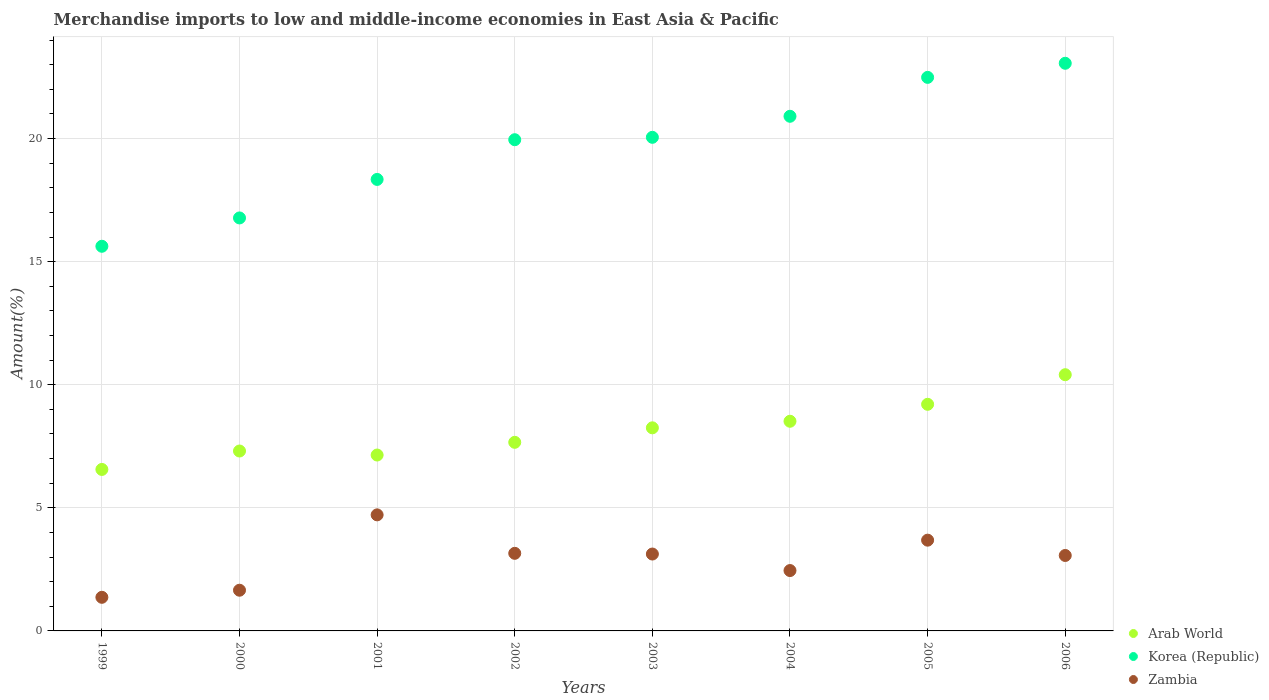How many different coloured dotlines are there?
Your response must be concise. 3. Is the number of dotlines equal to the number of legend labels?
Provide a short and direct response. Yes. What is the percentage of amount earned from merchandise imports in Arab World in 2004?
Your answer should be very brief. 8.52. Across all years, what is the maximum percentage of amount earned from merchandise imports in Zambia?
Your response must be concise. 4.71. Across all years, what is the minimum percentage of amount earned from merchandise imports in Zambia?
Make the answer very short. 1.37. What is the total percentage of amount earned from merchandise imports in Korea (Republic) in the graph?
Provide a short and direct response. 157.21. What is the difference between the percentage of amount earned from merchandise imports in Arab World in 2001 and that in 2003?
Keep it short and to the point. -1.11. What is the difference between the percentage of amount earned from merchandise imports in Zambia in 2003 and the percentage of amount earned from merchandise imports in Korea (Republic) in 1999?
Provide a succinct answer. -12.5. What is the average percentage of amount earned from merchandise imports in Zambia per year?
Offer a very short reply. 2.9. In the year 2002, what is the difference between the percentage of amount earned from merchandise imports in Zambia and percentage of amount earned from merchandise imports in Arab World?
Provide a succinct answer. -4.51. In how many years, is the percentage of amount earned from merchandise imports in Zambia greater than 10 %?
Your answer should be compact. 0. What is the ratio of the percentage of amount earned from merchandise imports in Korea (Republic) in 2001 to that in 2003?
Offer a very short reply. 0.91. What is the difference between the highest and the second highest percentage of amount earned from merchandise imports in Korea (Republic)?
Give a very brief answer. 0.57. What is the difference between the highest and the lowest percentage of amount earned from merchandise imports in Korea (Republic)?
Keep it short and to the point. 7.43. How many years are there in the graph?
Your response must be concise. 8. What is the difference between two consecutive major ticks on the Y-axis?
Offer a very short reply. 5. Where does the legend appear in the graph?
Your response must be concise. Bottom right. What is the title of the graph?
Your response must be concise. Merchandise imports to low and middle-income economies in East Asia & Pacific. What is the label or title of the Y-axis?
Ensure brevity in your answer.  Amount(%). What is the Amount(%) of Arab World in 1999?
Keep it short and to the point. 6.56. What is the Amount(%) of Korea (Republic) in 1999?
Keep it short and to the point. 15.63. What is the Amount(%) of Zambia in 1999?
Ensure brevity in your answer.  1.37. What is the Amount(%) of Arab World in 2000?
Your response must be concise. 7.31. What is the Amount(%) in Korea (Republic) in 2000?
Provide a short and direct response. 16.78. What is the Amount(%) in Zambia in 2000?
Your answer should be very brief. 1.65. What is the Amount(%) of Arab World in 2001?
Offer a terse response. 7.15. What is the Amount(%) of Korea (Republic) in 2001?
Offer a terse response. 18.34. What is the Amount(%) of Zambia in 2001?
Your answer should be compact. 4.71. What is the Amount(%) in Arab World in 2002?
Your answer should be very brief. 7.66. What is the Amount(%) of Korea (Republic) in 2002?
Your response must be concise. 19.96. What is the Amount(%) in Zambia in 2002?
Your response must be concise. 3.15. What is the Amount(%) of Arab World in 2003?
Offer a very short reply. 8.25. What is the Amount(%) of Korea (Republic) in 2003?
Ensure brevity in your answer.  20.05. What is the Amount(%) in Zambia in 2003?
Your answer should be compact. 3.12. What is the Amount(%) of Arab World in 2004?
Offer a terse response. 8.52. What is the Amount(%) in Korea (Republic) in 2004?
Offer a terse response. 20.91. What is the Amount(%) in Zambia in 2004?
Offer a very short reply. 2.45. What is the Amount(%) in Arab World in 2005?
Make the answer very short. 9.21. What is the Amount(%) of Korea (Republic) in 2005?
Your answer should be compact. 22.49. What is the Amount(%) of Zambia in 2005?
Your answer should be very brief. 3.69. What is the Amount(%) in Arab World in 2006?
Offer a terse response. 10.41. What is the Amount(%) in Korea (Republic) in 2006?
Make the answer very short. 23.06. What is the Amount(%) of Zambia in 2006?
Provide a short and direct response. 3.06. Across all years, what is the maximum Amount(%) of Arab World?
Ensure brevity in your answer.  10.41. Across all years, what is the maximum Amount(%) in Korea (Republic)?
Your answer should be very brief. 23.06. Across all years, what is the maximum Amount(%) of Zambia?
Offer a terse response. 4.71. Across all years, what is the minimum Amount(%) of Arab World?
Provide a succinct answer. 6.56. Across all years, what is the minimum Amount(%) of Korea (Republic)?
Your answer should be very brief. 15.63. Across all years, what is the minimum Amount(%) of Zambia?
Provide a succinct answer. 1.37. What is the total Amount(%) in Arab World in the graph?
Your answer should be very brief. 65.06. What is the total Amount(%) of Korea (Republic) in the graph?
Give a very brief answer. 157.21. What is the total Amount(%) in Zambia in the graph?
Keep it short and to the point. 23.21. What is the difference between the Amount(%) in Arab World in 1999 and that in 2000?
Your response must be concise. -0.75. What is the difference between the Amount(%) of Korea (Republic) in 1999 and that in 2000?
Your answer should be very brief. -1.15. What is the difference between the Amount(%) of Zambia in 1999 and that in 2000?
Provide a short and direct response. -0.29. What is the difference between the Amount(%) of Arab World in 1999 and that in 2001?
Your answer should be very brief. -0.59. What is the difference between the Amount(%) of Korea (Republic) in 1999 and that in 2001?
Your response must be concise. -2.72. What is the difference between the Amount(%) in Zambia in 1999 and that in 2001?
Provide a short and direct response. -3.35. What is the difference between the Amount(%) of Arab World in 1999 and that in 2002?
Your answer should be compact. -1.1. What is the difference between the Amount(%) in Korea (Republic) in 1999 and that in 2002?
Ensure brevity in your answer.  -4.33. What is the difference between the Amount(%) of Zambia in 1999 and that in 2002?
Offer a very short reply. -1.79. What is the difference between the Amount(%) of Arab World in 1999 and that in 2003?
Offer a terse response. -1.69. What is the difference between the Amount(%) in Korea (Republic) in 1999 and that in 2003?
Give a very brief answer. -4.43. What is the difference between the Amount(%) of Zambia in 1999 and that in 2003?
Keep it short and to the point. -1.76. What is the difference between the Amount(%) in Arab World in 1999 and that in 2004?
Offer a very short reply. -1.96. What is the difference between the Amount(%) of Korea (Republic) in 1999 and that in 2004?
Provide a short and direct response. -5.28. What is the difference between the Amount(%) in Zambia in 1999 and that in 2004?
Ensure brevity in your answer.  -1.09. What is the difference between the Amount(%) of Arab World in 1999 and that in 2005?
Your answer should be very brief. -2.65. What is the difference between the Amount(%) of Korea (Republic) in 1999 and that in 2005?
Keep it short and to the point. -6.86. What is the difference between the Amount(%) of Zambia in 1999 and that in 2005?
Offer a terse response. -2.32. What is the difference between the Amount(%) of Arab World in 1999 and that in 2006?
Provide a short and direct response. -3.85. What is the difference between the Amount(%) of Korea (Republic) in 1999 and that in 2006?
Give a very brief answer. -7.43. What is the difference between the Amount(%) of Zambia in 1999 and that in 2006?
Offer a terse response. -1.7. What is the difference between the Amount(%) in Arab World in 2000 and that in 2001?
Offer a very short reply. 0.16. What is the difference between the Amount(%) in Korea (Republic) in 2000 and that in 2001?
Your response must be concise. -1.56. What is the difference between the Amount(%) in Zambia in 2000 and that in 2001?
Provide a short and direct response. -3.06. What is the difference between the Amount(%) of Arab World in 2000 and that in 2002?
Give a very brief answer. -0.35. What is the difference between the Amount(%) in Korea (Republic) in 2000 and that in 2002?
Your answer should be compact. -3.18. What is the difference between the Amount(%) of Zambia in 2000 and that in 2002?
Provide a succinct answer. -1.5. What is the difference between the Amount(%) of Arab World in 2000 and that in 2003?
Your answer should be compact. -0.94. What is the difference between the Amount(%) of Korea (Republic) in 2000 and that in 2003?
Your answer should be compact. -3.28. What is the difference between the Amount(%) in Zambia in 2000 and that in 2003?
Your answer should be very brief. -1.47. What is the difference between the Amount(%) in Arab World in 2000 and that in 2004?
Your response must be concise. -1.21. What is the difference between the Amount(%) of Korea (Republic) in 2000 and that in 2004?
Keep it short and to the point. -4.13. What is the difference between the Amount(%) of Zambia in 2000 and that in 2004?
Provide a succinct answer. -0.8. What is the difference between the Amount(%) in Arab World in 2000 and that in 2005?
Provide a succinct answer. -1.9. What is the difference between the Amount(%) of Korea (Republic) in 2000 and that in 2005?
Ensure brevity in your answer.  -5.71. What is the difference between the Amount(%) of Zambia in 2000 and that in 2005?
Your answer should be compact. -2.03. What is the difference between the Amount(%) of Arab World in 2000 and that in 2006?
Offer a very short reply. -3.1. What is the difference between the Amount(%) in Korea (Republic) in 2000 and that in 2006?
Your answer should be compact. -6.28. What is the difference between the Amount(%) in Zambia in 2000 and that in 2006?
Provide a short and direct response. -1.41. What is the difference between the Amount(%) of Arab World in 2001 and that in 2002?
Ensure brevity in your answer.  -0.52. What is the difference between the Amount(%) of Korea (Republic) in 2001 and that in 2002?
Your answer should be very brief. -1.61. What is the difference between the Amount(%) in Zambia in 2001 and that in 2002?
Your response must be concise. 1.56. What is the difference between the Amount(%) in Arab World in 2001 and that in 2003?
Offer a very short reply. -1.11. What is the difference between the Amount(%) in Korea (Republic) in 2001 and that in 2003?
Make the answer very short. -1.71. What is the difference between the Amount(%) in Zambia in 2001 and that in 2003?
Give a very brief answer. 1.59. What is the difference between the Amount(%) in Arab World in 2001 and that in 2004?
Your response must be concise. -1.37. What is the difference between the Amount(%) in Korea (Republic) in 2001 and that in 2004?
Your response must be concise. -2.57. What is the difference between the Amount(%) in Zambia in 2001 and that in 2004?
Offer a terse response. 2.26. What is the difference between the Amount(%) of Arab World in 2001 and that in 2005?
Your answer should be very brief. -2.06. What is the difference between the Amount(%) in Korea (Republic) in 2001 and that in 2005?
Offer a very short reply. -4.15. What is the difference between the Amount(%) in Zambia in 2001 and that in 2005?
Keep it short and to the point. 1.03. What is the difference between the Amount(%) of Arab World in 2001 and that in 2006?
Your answer should be compact. -3.26. What is the difference between the Amount(%) in Korea (Republic) in 2001 and that in 2006?
Provide a succinct answer. -4.72. What is the difference between the Amount(%) of Zambia in 2001 and that in 2006?
Your answer should be very brief. 1.65. What is the difference between the Amount(%) in Arab World in 2002 and that in 2003?
Keep it short and to the point. -0.59. What is the difference between the Amount(%) of Korea (Republic) in 2002 and that in 2003?
Your response must be concise. -0.1. What is the difference between the Amount(%) of Zambia in 2002 and that in 2003?
Provide a short and direct response. 0.03. What is the difference between the Amount(%) of Arab World in 2002 and that in 2004?
Offer a terse response. -0.86. What is the difference between the Amount(%) of Korea (Republic) in 2002 and that in 2004?
Keep it short and to the point. -0.95. What is the difference between the Amount(%) in Zambia in 2002 and that in 2004?
Your response must be concise. 0.7. What is the difference between the Amount(%) of Arab World in 2002 and that in 2005?
Provide a short and direct response. -1.54. What is the difference between the Amount(%) of Korea (Republic) in 2002 and that in 2005?
Your answer should be compact. -2.53. What is the difference between the Amount(%) of Zambia in 2002 and that in 2005?
Your answer should be very brief. -0.53. What is the difference between the Amount(%) in Arab World in 2002 and that in 2006?
Provide a succinct answer. -2.75. What is the difference between the Amount(%) in Korea (Republic) in 2002 and that in 2006?
Give a very brief answer. -3.1. What is the difference between the Amount(%) of Zambia in 2002 and that in 2006?
Provide a short and direct response. 0.09. What is the difference between the Amount(%) of Arab World in 2003 and that in 2004?
Provide a succinct answer. -0.27. What is the difference between the Amount(%) in Korea (Republic) in 2003 and that in 2004?
Offer a very short reply. -0.85. What is the difference between the Amount(%) in Zambia in 2003 and that in 2004?
Provide a short and direct response. 0.67. What is the difference between the Amount(%) in Arab World in 2003 and that in 2005?
Keep it short and to the point. -0.96. What is the difference between the Amount(%) of Korea (Republic) in 2003 and that in 2005?
Your answer should be compact. -2.44. What is the difference between the Amount(%) of Zambia in 2003 and that in 2005?
Your response must be concise. -0.56. What is the difference between the Amount(%) in Arab World in 2003 and that in 2006?
Provide a succinct answer. -2.16. What is the difference between the Amount(%) in Korea (Republic) in 2003 and that in 2006?
Keep it short and to the point. -3.01. What is the difference between the Amount(%) in Zambia in 2003 and that in 2006?
Ensure brevity in your answer.  0.06. What is the difference between the Amount(%) of Arab World in 2004 and that in 2005?
Provide a succinct answer. -0.69. What is the difference between the Amount(%) in Korea (Republic) in 2004 and that in 2005?
Your answer should be compact. -1.58. What is the difference between the Amount(%) of Zambia in 2004 and that in 2005?
Offer a terse response. -1.23. What is the difference between the Amount(%) of Arab World in 2004 and that in 2006?
Your answer should be compact. -1.89. What is the difference between the Amount(%) in Korea (Republic) in 2004 and that in 2006?
Offer a terse response. -2.15. What is the difference between the Amount(%) in Zambia in 2004 and that in 2006?
Your answer should be very brief. -0.61. What is the difference between the Amount(%) in Arab World in 2005 and that in 2006?
Your response must be concise. -1.2. What is the difference between the Amount(%) in Korea (Republic) in 2005 and that in 2006?
Provide a short and direct response. -0.57. What is the difference between the Amount(%) of Zambia in 2005 and that in 2006?
Make the answer very short. 0.62. What is the difference between the Amount(%) in Arab World in 1999 and the Amount(%) in Korea (Republic) in 2000?
Your response must be concise. -10.22. What is the difference between the Amount(%) of Arab World in 1999 and the Amount(%) of Zambia in 2000?
Provide a short and direct response. 4.91. What is the difference between the Amount(%) of Korea (Republic) in 1999 and the Amount(%) of Zambia in 2000?
Keep it short and to the point. 13.97. What is the difference between the Amount(%) of Arab World in 1999 and the Amount(%) of Korea (Republic) in 2001?
Your answer should be compact. -11.78. What is the difference between the Amount(%) in Arab World in 1999 and the Amount(%) in Zambia in 2001?
Your answer should be very brief. 1.84. What is the difference between the Amount(%) in Korea (Republic) in 1999 and the Amount(%) in Zambia in 2001?
Provide a short and direct response. 10.91. What is the difference between the Amount(%) of Arab World in 1999 and the Amount(%) of Korea (Republic) in 2002?
Ensure brevity in your answer.  -13.4. What is the difference between the Amount(%) of Arab World in 1999 and the Amount(%) of Zambia in 2002?
Your response must be concise. 3.41. What is the difference between the Amount(%) of Korea (Republic) in 1999 and the Amount(%) of Zambia in 2002?
Your answer should be compact. 12.47. What is the difference between the Amount(%) of Arab World in 1999 and the Amount(%) of Korea (Republic) in 2003?
Your answer should be compact. -13.49. What is the difference between the Amount(%) in Arab World in 1999 and the Amount(%) in Zambia in 2003?
Ensure brevity in your answer.  3.44. What is the difference between the Amount(%) in Korea (Republic) in 1999 and the Amount(%) in Zambia in 2003?
Offer a terse response. 12.5. What is the difference between the Amount(%) in Arab World in 1999 and the Amount(%) in Korea (Republic) in 2004?
Your answer should be compact. -14.35. What is the difference between the Amount(%) of Arab World in 1999 and the Amount(%) of Zambia in 2004?
Your answer should be very brief. 4.11. What is the difference between the Amount(%) in Korea (Republic) in 1999 and the Amount(%) in Zambia in 2004?
Make the answer very short. 13.17. What is the difference between the Amount(%) in Arab World in 1999 and the Amount(%) in Korea (Republic) in 2005?
Give a very brief answer. -15.93. What is the difference between the Amount(%) in Arab World in 1999 and the Amount(%) in Zambia in 2005?
Provide a short and direct response. 2.87. What is the difference between the Amount(%) of Korea (Republic) in 1999 and the Amount(%) of Zambia in 2005?
Give a very brief answer. 11.94. What is the difference between the Amount(%) of Arab World in 1999 and the Amount(%) of Korea (Republic) in 2006?
Your response must be concise. -16.5. What is the difference between the Amount(%) in Arab World in 1999 and the Amount(%) in Zambia in 2006?
Make the answer very short. 3.5. What is the difference between the Amount(%) of Korea (Republic) in 1999 and the Amount(%) of Zambia in 2006?
Make the answer very short. 12.56. What is the difference between the Amount(%) in Arab World in 2000 and the Amount(%) in Korea (Republic) in 2001?
Provide a short and direct response. -11.03. What is the difference between the Amount(%) of Arab World in 2000 and the Amount(%) of Zambia in 2001?
Offer a terse response. 2.59. What is the difference between the Amount(%) of Korea (Republic) in 2000 and the Amount(%) of Zambia in 2001?
Offer a very short reply. 12.06. What is the difference between the Amount(%) of Arab World in 2000 and the Amount(%) of Korea (Republic) in 2002?
Provide a succinct answer. -12.65. What is the difference between the Amount(%) in Arab World in 2000 and the Amount(%) in Zambia in 2002?
Your response must be concise. 4.16. What is the difference between the Amount(%) in Korea (Republic) in 2000 and the Amount(%) in Zambia in 2002?
Your response must be concise. 13.62. What is the difference between the Amount(%) of Arab World in 2000 and the Amount(%) of Korea (Republic) in 2003?
Make the answer very short. -12.74. What is the difference between the Amount(%) in Arab World in 2000 and the Amount(%) in Zambia in 2003?
Make the answer very short. 4.18. What is the difference between the Amount(%) in Korea (Republic) in 2000 and the Amount(%) in Zambia in 2003?
Ensure brevity in your answer.  13.65. What is the difference between the Amount(%) of Arab World in 2000 and the Amount(%) of Korea (Republic) in 2004?
Offer a very short reply. -13.6. What is the difference between the Amount(%) in Arab World in 2000 and the Amount(%) in Zambia in 2004?
Make the answer very short. 4.86. What is the difference between the Amount(%) in Korea (Republic) in 2000 and the Amount(%) in Zambia in 2004?
Your response must be concise. 14.32. What is the difference between the Amount(%) of Arab World in 2000 and the Amount(%) of Korea (Republic) in 2005?
Offer a terse response. -15.18. What is the difference between the Amount(%) in Arab World in 2000 and the Amount(%) in Zambia in 2005?
Your response must be concise. 3.62. What is the difference between the Amount(%) of Korea (Republic) in 2000 and the Amount(%) of Zambia in 2005?
Your answer should be very brief. 13.09. What is the difference between the Amount(%) of Arab World in 2000 and the Amount(%) of Korea (Republic) in 2006?
Keep it short and to the point. -15.75. What is the difference between the Amount(%) in Arab World in 2000 and the Amount(%) in Zambia in 2006?
Provide a short and direct response. 4.24. What is the difference between the Amount(%) of Korea (Republic) in 2000 and the Amount(%) of Zambia in 2006?
Make the answer very short. 13.71. What is the difference between the Amount(%) of Arab World in 2001 and the Amount(%) of Korea (Republic) in 2002?
Your response must be concise. -12.81. What is the difference between the Amount(%) in Arab World in 2001 and the Amount(%) in Zambia in 2002?
Give a very brief answer. 3.99. What is the difference between the Amount(%) of Korea (Republic) in 2001 and the Amount(%) of Zambia in 2002?
Provide a short and direct response. 15.19. What is the difference between the Amount(%) in Arab World in 2001 and the Amount(%) in Korea (Republic) in 2003?
Give a very brief answer. -12.91. What is the difference between the Amount(%) in Arab World in 2001 and the Amount(%) in Zambia in 2003?
Your response must be concise. 4.02. What is the difference between the Amount(%) of Korea (Republic) in 2001 and the Amount(%) of Zambia in 2003?
Your answer should be compact. 15.22. What is the difference between the Amount(%) in Arab World in 2001 and the Amount(%) in Korea (Republic) in 2004?
Your response must be concise. -13.76. What is the difference between the Amount(%) in Arab World in 2001 and the Amount(%) in Zambia in 2004?
Your answer should be very brief. 4.69. What is the difference between the Amount(%) of Korea (Republic) in 2001 and the Amount(%) of Zambia in 2004?
Your response must be concise. 15.89. What is the difference between the Amount(%) of Arab World in 2001 and the Amount(%) of Korea (Republic) in 2005?
Your answer should be very brief. -15.34. What is the difference between the Amount(%) in Arab World in 2001 and the Amount(%) in Zambia in 2005?
Your response must be concise. 3.46. What is the difference between the Amount(%) in Korea (Republic) in 2001 and the Amount(%) in Zambia in 2005?
Ensure brevity in your answer.  14.65. What is the difference between the Amount(%) of Arab World in 2001 and the Amount(%) of Korea (Republic) in 2006?
Provide a short and direct response. -15.91. What is the difference between the Amount(%) in Arab World in 2001 and the Amount(%) in Zambia in 2006?
Your answer should be compact. 4.08. What is the difference between the Amount(%) in Korea (Republic) in 2001 and the Amount(%) in Zambia in 2006?
Offer a very short reply. 15.28. What is the difference between the Amount(%) of Arab World in 2002 and the Amount(%) of Korea (Republic) in 2003?
Your response must be concise. -12.39. What is the difference between the Amount(%) of Arab World in 2002 and the Amount(%) of Zambia in 2003?
Ensure brevity in your answer.  4.54. What is the difference between the Amount(%) of Korea (Republic) in 2002 and the Amount(%) of Zambia in 2003?
Ensure brevity in your answer.  16.83. What is the difference between the Amount(%) in Arab World in 2002 and the Amount(%) in Korea (Republic) in 2004?
Offer a terse response. -13.25. What is the difference between the Amount(%) of Arab World in 2002 and the Amount(%) of Zambia in 2004?
Ensure brevity in your answer.  5.21. What is the difference between the Amount(%) in Korea (Republic) in 2002 and the Amount(%) in Zambia in 2004?
Offer a very short reply. 17.5. What is the difference between the Amount(%) of Arab World in 2002 and the Amount(%) of Korea (Republic) in 2005?
Provide a short and direct response. -14.83. What is the difference between the Amount(%) of Arab World in 2002 and the Amount(%) of Zambia in 2005?
Your response must be concise. 3.97. What is the difference between the Amount(%) in Korea (Republic) in 2002 and the Amount(%) in Zambia in 2005?
Offer a terse response. 16.27. What is the difference between the Amount(%) in Arab World in 2002 and the Amount(%) in Korea (Republic) in 2006?
Offer a very short reply. -15.4. What is the difference between the Amount(%) in Arab World in 2002 and the Amount(%) in Zambia in 2006?
Your answer should be very brief. 4.6. What is the difference between the Amount(%) of Korea (Republic) in 2002 and the Amount(%) of Zambia in 2006?
Make the answer very short. 16.89. What is the difference between the Amount(%) in Arab World in 2003 and the Amount(%) in Korea (Republic) in 2004?
Offer a very short reply. -12.66. What is the difference between the Amount(%) of Arab World in 2003 and the Amount(%) of Zambia in 2004?
Offer a terse response. 5.8. What is the difference between the Amount(%) of Korea (Republic) in 2003 and the Amount(%) of Zambia in 2004?
Provide a succinct answer. 17.6. What is the difference between the Amount(%) in Arab World in 2003 and the Amount(%) in Korea (Republic) in 2005?
Your answer should be very brief. -14.24. What is the difference between the Amount(%) in Arab World in 2003 and the Amount(%) in Zambia in 2005?
Keep it short and to the point. 4.56. What is the difference between the Amount(%) in Korea (Republic) in 2003 and the Amount(%) in Zambia in 2005?
Offer a very short reply. 16.37. What is the difference between the Amount(%) of Arab World in 2003 and the Amount(%) of Korea (Republic) in 2006?
Offer a terse response. -14.81. What is the difference between the Amount(%) of Arab World in 2003 and the Amount(%) of Zambia in 2006?
Your response must be concise. 5.19. What is the difference between the Amount(%) of Korea (Republic) in 2003 and the Amount(%) of Zambia in 2006?
Your answer should be very brief. 16.99. What is the difference between the Amount(%) of Arab World in 2004 and the Amount(%) of Korea (Republic) in 2005?
Provide a short and direct response. -13.97. What is the difference between the Amount(%) of Arab World in 2004 and the Amount(%) of Zambia in 2005?
Provide a short and direct response. 4.83. What is the difference between the Amount(%) in Korea (Republic) in 2004 and the Amount(%) in Zambia in 2005?
Your answer should be very brief. 17.22. What is the difference between the Amount(%) of Arab World in 2004 and the Amount(%) of Korea (Republic) in 2006?
Offer a terse response. -14.54. What is the difference between the Amount(%) in Arab World in 2004 and the Amount(%) in Zambia in 2006?
Your response must be concise. 5.45. What is the difference between the Amount(%) of Korea (Republic) in 2004 and the Amount(%) of Zambia in 2006?
Provide a short and direct response. 17.84. What is the difference between the Amount(%) of Arab World in 2005 and the Amount(%) of Korea (Republic) in 2006?
Your answer should be compact. -13.85. What is the difference between the Amount(%) in Arab World in 2005 and the Amount(%) in Zambia in 2006?
Your response must be concise. 6.14. What is the difference between the Amount(%) of Korea (Republic) in 2005 and the Amount(%) of Zambia in 2006?
Offer a terse response. 19.42. What is the average Amount(%) of Arab World per year?
Offer a very short reply. 8.13. What is the average Amount(%) of Korea (Republic) per year?
Offer a terse response. 19.65. What is the average Amount(%) of Zambia per year?
Keep it short and to the point. 2.9. In the year 1999, what is the difference between the Amount(%) of Arab World and Amount(%) of Korea (Republic)?
Your answer should be very brief. -9.07. In the year 1999, what is the difference between the Amount(%) in Arab World and Amount(%) in Zambia?
Keep it short and to the point. 5.19. In the year 1999, what is the difference between the Amount(%) of Korea (Republic) and Amount(%) of Zambia?
Give a very brief answer. 14.26. In the year 2000, what is the difference between the Amount(%) in Arab World and Amount(%) in Korea (Republic)?
Your response must be concise. -9.47. In the year 2000, what is the difference between the Amount(%) in Arab World and Amount(%) in Zambia?
Offer a terse response. 5.66. In the year 2000, what is the difference between the Amount(%) of Korea (Republic) and Amount(%) of Zambia?
Your response must be concise. 15.12. In the year 2001, what is the difference between the Amount(%) in Arab World and Amount(%) in Korea (Republic)?
Provide a short and direct response. -11.2. In the year 2001, what is the difference between the Amount(%) of Arab World and Amount(%) of Zambia?
Offer a terse response. 2.43. In the year 2001, what is the difference between the Amount(%) of Korea (Republic) and Amount(%) of Zambia?
Your answer should be very brief. 13.63. In the year 2002, what is the difference between the Amount(%) in Arab World and Amount(%) in Korea (Republic)?
Your answer should be compact. -12.29. In the year 2002, what is the difference between the Amount(%) of Arab World and Amount(%) of Zambia?
Make the answer very short. 4.51. In the year 2002, what is the difference between the Amount(%) in Korea (Republic) and Amount(%) in Zambia?
Offer a very short reply. 16.8. In the year 2003, what is the difference between the Amount(%) of Arab World and Amount(%) of Korea (Republic)?
Keep it short and to the point. -11.8. In the year 2003, what is the difference between the Amount(%) in Arab World and Amount(%) in Zambia?
Offer a terse response. 5.13. In the year 2003, what is the difference between the Amount(%) in Korea (Republic) and Amount(%) in Zambia?
Your response must be concise. 16.93. In the year 2004, what is the difference between the Amount(%) in Arab World and Amount(%) in Korea (Republic)?
Make the answer very short. -12.39. In the year 2004, what is the difference between the Amount(%) in Arab World and Amount(%) in Zambia?
Your response must be concise. 6.06. In the year 2004, what is the difference between the Amount(%) of Korea (Republic) and Amount(%) of Zambia?
Offer a terse response. 18.45. In the year 2005, what is the difference between the Amount(%) in Arab World and Amount(%) in Korea (Republic)?
Your answer should be compact. -13.28. In the year 2005, what is the difference between the Amount(%) of Arab World and Amount(%) of Zambia?
Offer a terse response. 5.52. In the year 2005, what is the difference between the Amount(%) of Korea (Republic) and Amount(%) of Zambia?
Provide a short and direct response. 18.8. In the year 2006, what is the difference between the Amount(%) in Arab World and Amount(%) in Korea (Republic)?
Provide a short and direct response. -12.65. In the year 2006, what is the difference between the Amount(%) of Arab World and Amount(%) of Zambia?
Your answer should be compact. 7.34. In the year 2006, what is the difference between the Amount(%) of Korea (Republic) and Amount(%) of Zambia?
Provide a succinct answer. 20. What is the ratio of the Amount(%) of Arab World in 1999 to that in 2000?
Provide a short and direct response. 0.9. What is the ratio of the Amount(%) in Korea (Republic) in 1999 to that in 2000?
Keep it short and to the point. 0.93. What is the ratio of the Amount(%) in Zambia in 1999 to that in 2000?
Give a very brief answer. 0.83. What is the ratio of the Amount(%) in Arab World in 1999 to that in 2001?
Make the answer very short. 0.92. What is the ratio of the Amount(%) in Korea (Republic) in 1999 to that in 2001?
Give a very brief answer. 0.85. What is the ratio of the Amount(%) of Zambia in 1999 to that in 2001?
Your response must be concise. 0.29. What is the ratio of the Amount(%) in Arab World in 1999 to that in 2002?
Offer a terse response. 0.86. What is the ratio of the Amount(%) in Korea (Republic) in 1999 to that in 2002?
Your answer should be compact. 0.78. What is the ratio of the Amount(%) in Zambia in 1999 to that in 2002?
Ensure brevity in your answer.  0.43. What is the ratio of the Amount(%) in Arab World in 1999 to that in 2003?
Ensure brevity in your answer.  0.8. What is the ratio of the Amount(%) of Korea (Republic) in 1999 to that in 2003?
Provide a short and direct response. 0.78. What is the ratio of the Amount(%) in Zambia in 1999 to that in 2003?
Give a very brief answer. 0.44. What is the ratio of the Amount(%) of Arab World in 1999 to that in 2004?
Make the answer very short. 0.77. What is the ratio of the Amount(%) in Korea (Republic) in 1999 to that in 2004?
Provide a short and direct response. 0.75. What is the ratio of the Amount(%) in Zambia in 1999 to that in 2004?
Your answer should be very brief. 0.56. What is the ratio of the Amount(%) in Arab World in 1999 to that in 2005?
Provide a short and direct response. 0.71. What is the ratio of the Amount(%) in Korea (Republic) in 1999 to that in 2005?
Offer a terse response. 0.69. What is the ratio of the Amount(%) of Zambia in 1999 to that in 2005?
Make the answer very short. 0.37. What is the ratio of the Amount(%) in Arab World in 1999 to that in 2006?
Offer a very short reply. 0.63. What is the ratio of the Amount(%) in Korea (Republic) in 1999 to that in 2006?
Provide a succinct answer. 0.68. What is the ratio of the Amount(%) in Zambia in 1999 to that in 2006?
Provide a succinct answer. 0.45. What is the ratio of the Amount(%) of Arab World in 2000 to that in 2001?
Ensure brevity in your answer.  1.02. What is the ratio of the Amount(%) of Korea (Republic) in 2000 to that in 2001?
Ensure brevity in your answer.  0.91. What is the ratio of the Amount(%) in Zambia in 2000 to that in 2001?
Offer a terse response. 0.35. What is the ratio of the Amount(%) in Arab World in 2000 to that in 2002?
Your answer should be compact. 0.95. What is the ratio of the Amount(%) in Korea (Republic) in 2000 to that in 2002?
Your response must be concise. 0.84. What is the ratio of the Amount(%) in Zambia in 2000 to that in 2002?
Keep it short and to the point. 0.52. What is the ratio of the Amount(%) of Arab World in 2000 to that in 2003?
Provide a short and direct response. 0.89. What is the ratio of the Amount(%) of Korea (Republic) in 2000 to that in 2003?
Give a very brief answer. 0.84. What is the ratio of the Amount(%) of Zambia in 2000 to that in 2003?
Your answer should be compact. 0.53. What is the ratio of the Amount(%) of Arab World in 2000 to that in 2004?
Ensure brevity in your answer.  0.86. What is the ratio of the Amount(%) in Korea (Republic) in 2000 to that in 2004?
Your answer should be very brief. 0.8. What is the ratio of the Amount(%) in Zambia in 2000 to that in 2004?
Make the answer very short. 0.67. What is the ratio of the Amount(%) in Arab World in 2000 to that in 2005?
Offer a terse response. 0.79. What is the ratio of the Amount(%) in Korea (Republic) in 2000 to that in 2005?
Ensure brevity in your answer.  0.75. What is the ratio of the Amount(%) in Zambia in 2000 to that in 2005?
Your response must be concise. 0.45. What is the ratio of the Amount(%) of Arab World in 2000 to that in 2006?
Provide a short and direct response. 0.7. What is the ratio of the Amount(%) in Korea (Republic) in 2000 to that in 2006?
Offer a very short reply. 0.73. What is the ratio of the Amount(%) in Zambia in 2000 to that in 2006?
Give a very brief answer. 0.54. What is the ratio of the Amount(%) in Arab World in 2001 to that in 2002?
Your answer should be compact. 0.93. What is the ratio of the Amount(%) of Korea (Republic) in 2001 to that in 2002?
Ensure brevity in your answer.  0.92. What is the ratio of the Amount(%) in Zambia in 2001 to that in 2002?
Provide a succinct answer. 1.5. What is the ratio of the Amount(%) in Arab World in 2001 to that in 2003?
Your response must be concise. 0.87. What is the ratio of the Amount(%) of Korea (Republic) in 2001 to that in 2003?
Give a very brief answer. 0.91. What is the ratio of the Amount(%) in Zambia in 2001 to that in 2003?
Give a very brief answer. 1.51. What is the ratio of the Amount(%) in Arab World in 2001 to that in 2004?
Provide a succinct answer. 0.84. What is the ratio of the Amount(%) of Korea (Republic) in 2001 to that in 2004?
Your answer should be very brief. 0.88. What is the ratio of the Amount(%) in Zambia in 2001 to that in 2004?
Give a very brief answer. 1.92. What is the ratio of the Amount(%) in Arab World in 2001 to that in 2005?
Offer a very short reply. 0.78. What is the ratio of the Amount(%) in Korea (Republic) in 2001 to that in 2005?
Give a very brief answer. 0.82. What is the ratio of the Amount(%) of Zambia in 2001 to that in 2005?
Offer a terse response. 1.28. What is the ratio of the Amount(%) in Arab World in 2001 to that in 2006?
Give a very brief answer. 0.69. What is the ratio of the Amount(%) of Korea (Republic) in 2001 to that in 2006?
Provide a short and direct response. 0.8. What is the ratio of the Amount(%) of Zambia in 2001 to that in 2006?
Provide a short and direct response. 1.54. What is the ratio of the Amount(%) of Korea (Republic) in 2002 to that in 2003?
Offer a very short reply. 1. What is the ratio of the Amount(%) of Zambia in 2002 to that in 2003?
Keep it short and to the point. 1.01. What is the ratio of the Amount(%) in Arab World in 2002 to that in 2004?
Your response must be concise. 0.9. What is the ratio of the Amount(%) of Korea (Republic) in 2002 to that in 2004?
Offer a very short reply. 0.95. What is the ratio of the Amount(%) of Zambia in 2002 to that in 2004?
Provide a succinct answer. 1.29. What is the ratio of the Amount(%) in Arab World in 2002 to that in 2005?
Ensure brevity in your answer.  0.83. What is the ratio of the Amount(%) in Korea (Republic) in 2002 to that in 2005?
Provide a succinct answer. 0.89. What is the ratio of the Amount(%) of Zambia in 2002 to that in 2005?
Your answer should be very brief. 0.85. What is the ratio of the Amount(%) of Arab World in 2002 to that in 2006?
Keep it short and to the point. 0.74. What is the ratio of the Amount(%) of Korea (Republic) in 2002 to that in 2006?
Ensure brevity in your answer.  0.87. What is the ratio of the Amount(%) of Zambia in 2002 to that in 2006?
Ensure brevity in your answer.  1.03. What is the ratio of the Amount(%) in Arab World in 2003 to that in 2004?
Provide a succinct answer. 0.97. What is the ratio of the Amount(%) in Korea (Republic) in 2003 to that in 2004?
Provide a short and direct response. 0.96. What is the ratio of the Amount(%) in Zambia in 2003 to that in 2004?
Provide a succinct answer. 1.27. What is the ratio of the Amount(%) in Arab World in 2003 to that in 2005?
Ensure brevity in your answer.  0.9. What is the ratio of the Amount(%) in Korea (Republic) in 2003 to that in 2005?
Provide a short and direct response. 0.89. What is the ratio of the Amount(%) in Zambia in 2003 to that in 2005?
Your answer should be very brief. 0.85. What is the ratio of the Amount(%) in Arab World in 2003 to that in 2006?
Your response must be concise. 0.79. What is the ratio of the Amount(%) of Korea (Republic) in 2003 to that in 2006?
Offer a very short reply. 0.87. What is the ratio of the Amount(%) of Zambia in 2003 to that in 2006?
Offer a very short reply. 1.02. What is the ratio of the Amount(%) of Arab World in 2004 to that in 2005?
Make the answer very short. 0.93. What is the ratio of the Amount(%) of Korea (Republic) in 2004 to that in 2005?
Keep it short and to the point. 0.93. What is the ratio of the Amount(%) in Zambia in 2004 to that in 2005?
Your answer should be compact. 0.67. What is the ratio of the Amount(%) in Arab World in 2004 to that in 2006?
Keep it short and to the point. 0.82. What is the ratio of the Amount(%) in Korea (Republic) in 2004 to that in 2006?
Your answer should be compact. 0.91. What is the ratio of the Amount(%) in Zambia in 2004 to that in 2006?
Offer a terse response. 0.8. What is the ratio of the Amount(%) of Arab World in 2005 to that in 2006?
Keep it short and to the point. 0.88. What is the ratio of the Amount(%) in Korea (Republic) in 2005 to that in 2006?
Keep it short and to the point. 0.98. What is the ratio of the Amount(%) in Zambia in 2005 to that in 2006?
Offer a very short reply. 1.2. What is the difference between the highest and the second highest Amount(%) in Arab World?
Make the answer very short. 1.2. What is the difference between the highest and the second highest Amount(%) in Korea (Republic)?
Give a very brief answer. 0.57. What is the difference between the highest and the second highest Amount(%) of Zambia?
Make the answer very short. 1.03. What is the difference between the highest and the lowest Amount(%) in Arab World?
Your answer should be compact. 3.85. What is the difference between the highest and the lowest Amount(%) in Korea (Republic)?
Your response must be concise. 7.43. What is the difference between the highest and the lowest Amount(%) in Zambia?
Provide a short and direct response. 3.35. 